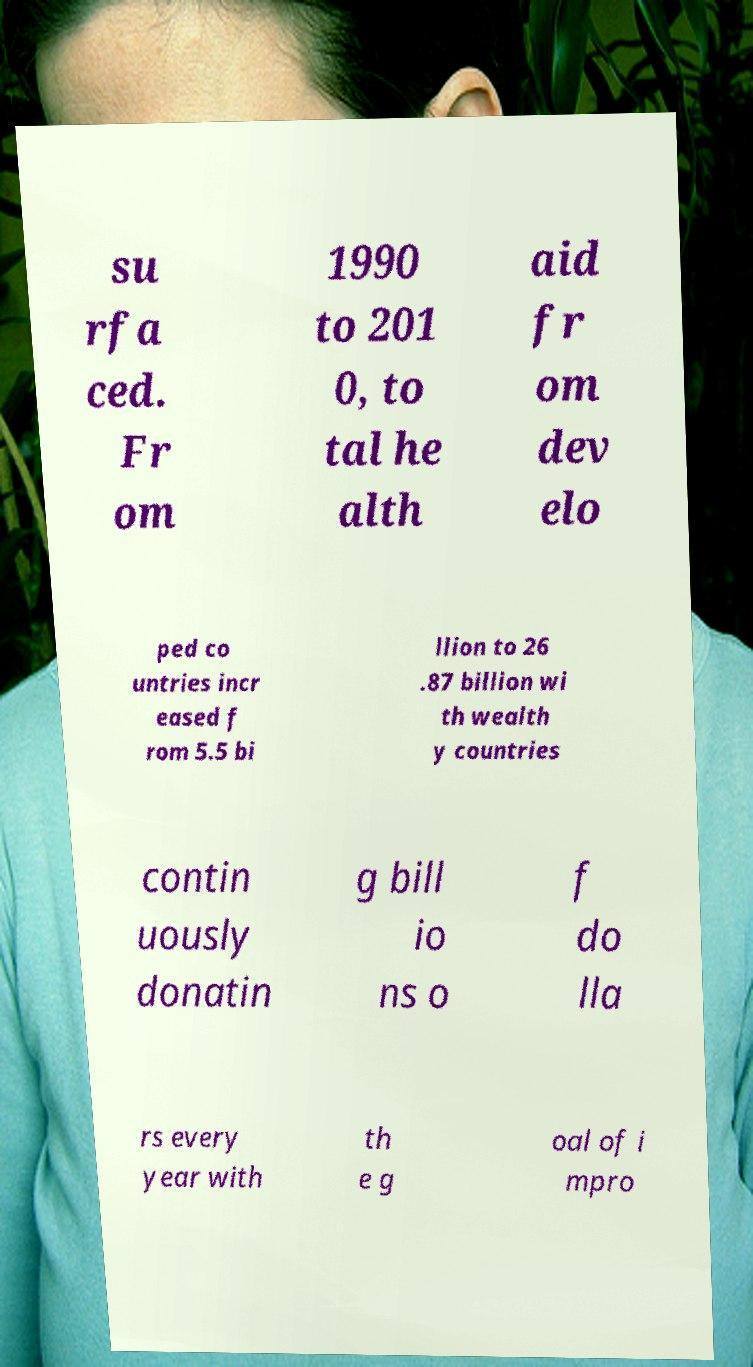Could you extract and type out the text from this image? su rfa ced. Fr om 1990 to 201 0, to tal he alth aid fr om dev elo ped co untries incr eased f rom 5.5 bi llion to 26 .87 billion wi th wealth y countries contin uously donatin g bill io ns o f do lla rs every year with th e g oal of i mpro 